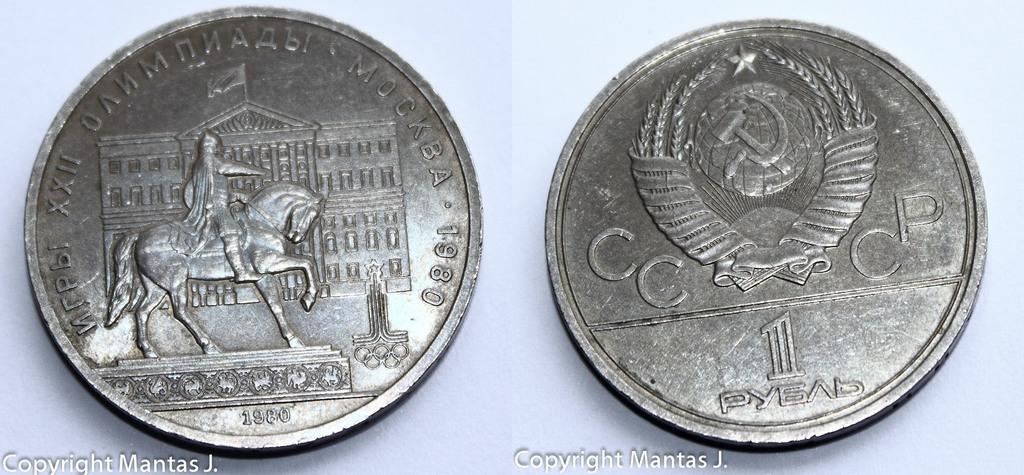Provide a one-sentence caption for the provided image. two silver coins with one of them that says cc and cp on it. 